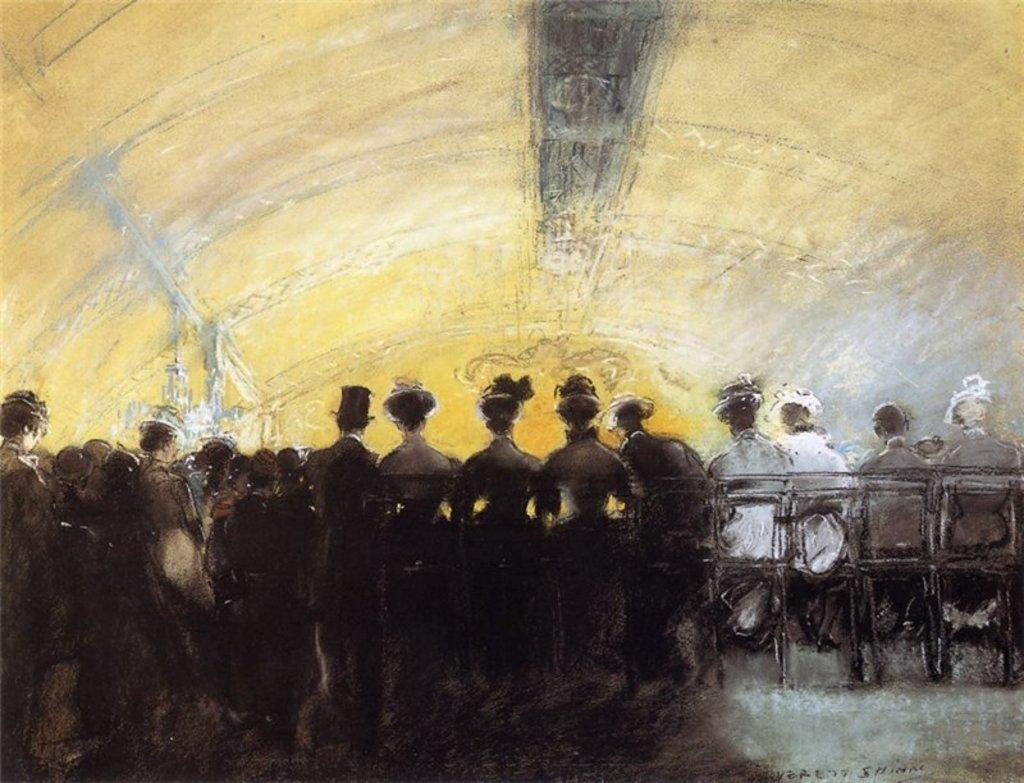What is the main subject of the image? There is a painting in the image. What is the painting depicting? The painting depicts a group of persons. Can you describe the positions of some persons in the painting? Some persons in the painting are sitting on chairs. What type of nose can be seen on the butter in the image? There is no butter present in the image, and therefore no nose can be seen on it. 